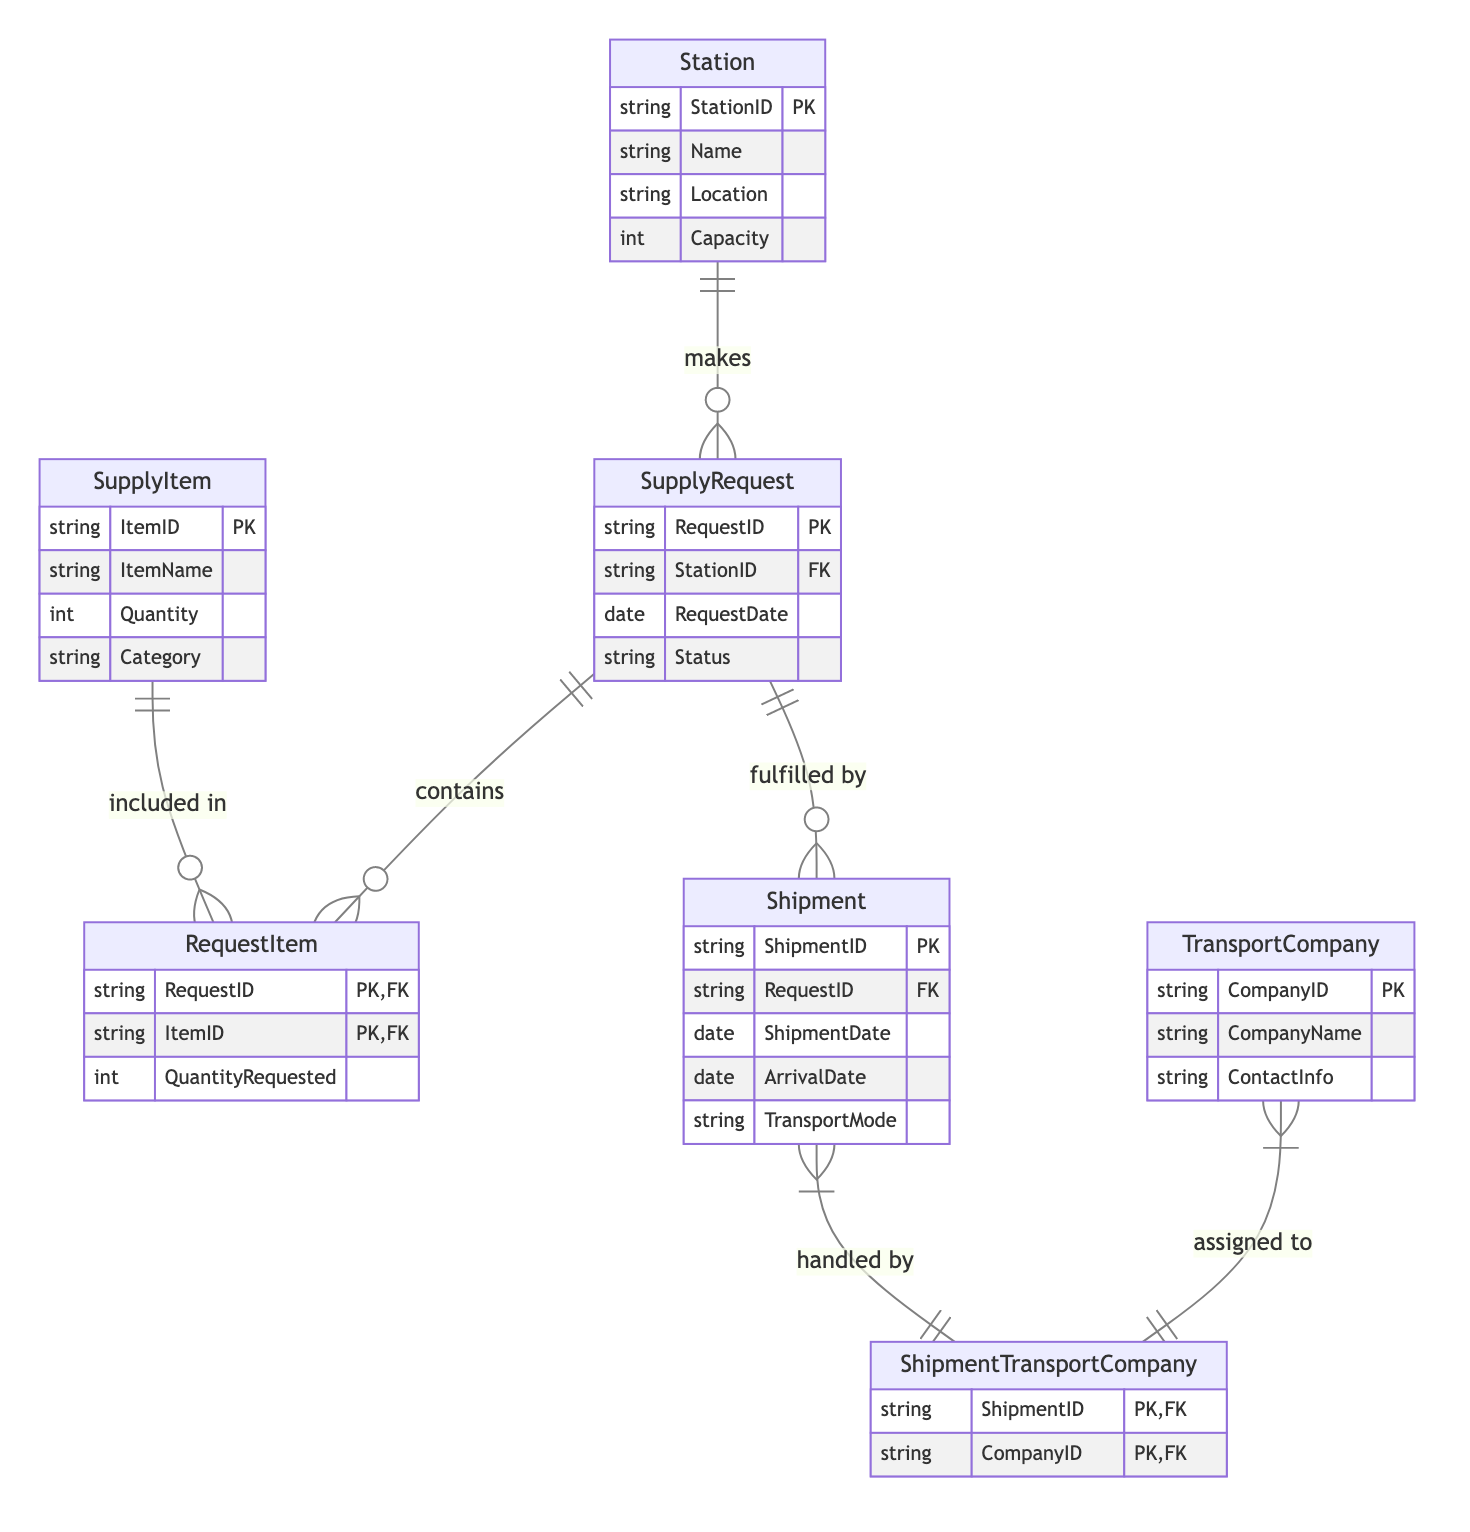What is the primary key of the Station entity? The primary key is defined in the Station entity, which is specified as StationID. This means each station is uniquely identified by this attribute.
Answer: StationID How many attributes does the SupplyRequest entity have? The attributes of the SupplyRequest entity are listed as RequestID, StationID, RequestDate, and Status, making a total of four attributes.
Answer: 4 What does the Shipment entity fulfill? The Shipment entity is connected to the SupplyRequest entity with a "fulfilled by" relationship, indicating that each shipment is associated with a particular supply request it fulfills.
Answer: SupplyRequest What is the relationship type between SupplyItem and RequestItem? The diagram shows a one-to-many relationship between SupplyItem and RequestItem, meaning each supply item can be included in multiple request items.
Answer: One-to-Many Which entity can be involved in handling multiple shipments? The TransportCompany entity is shown to have a many-to-many relationship with the Shipment entity through the ShipmentTransportCompany junction table, indicating that one transport company can handle multiple shipments.
Answer: TransportCompany How many foreign keys does the RequestItem entity have? The foreign keys in the RequestItem entity are RequestID and ItemID. Counting these gives a total of two foreign keys present in this entity.
Answer: 2 Which entity has the relationship "makes" with the SupplyRequest? The Station entity is depicted in the diagram with a "makes" relationship towards the SupplyRequest entity, indicating that each station can create multiple supply requests.
Answer: Station What is the transport mode relating to the Shipment entity? The Shipment entity has an attribute called TransportMode, which is used to specify the mode of transportation used for each shipment.
Answer: TransportMode What is the junction table connecting the Shipment and TransportCompany entities? The ShipmentTransportCompany is represented as the junction table connecting the many-to-many relationship between Shipment and TransportCompany entities.
Answer: ShipmentTransportCompany 